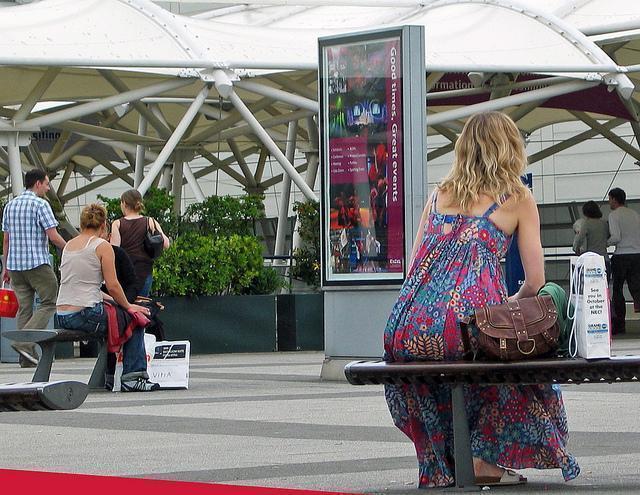What color is the leather of the woman's purse who is sitting on the bench to the right?
Answer the question by selecting the correct answer among the 4 following choices.
Options: White, black, cream, tan. Tan. 